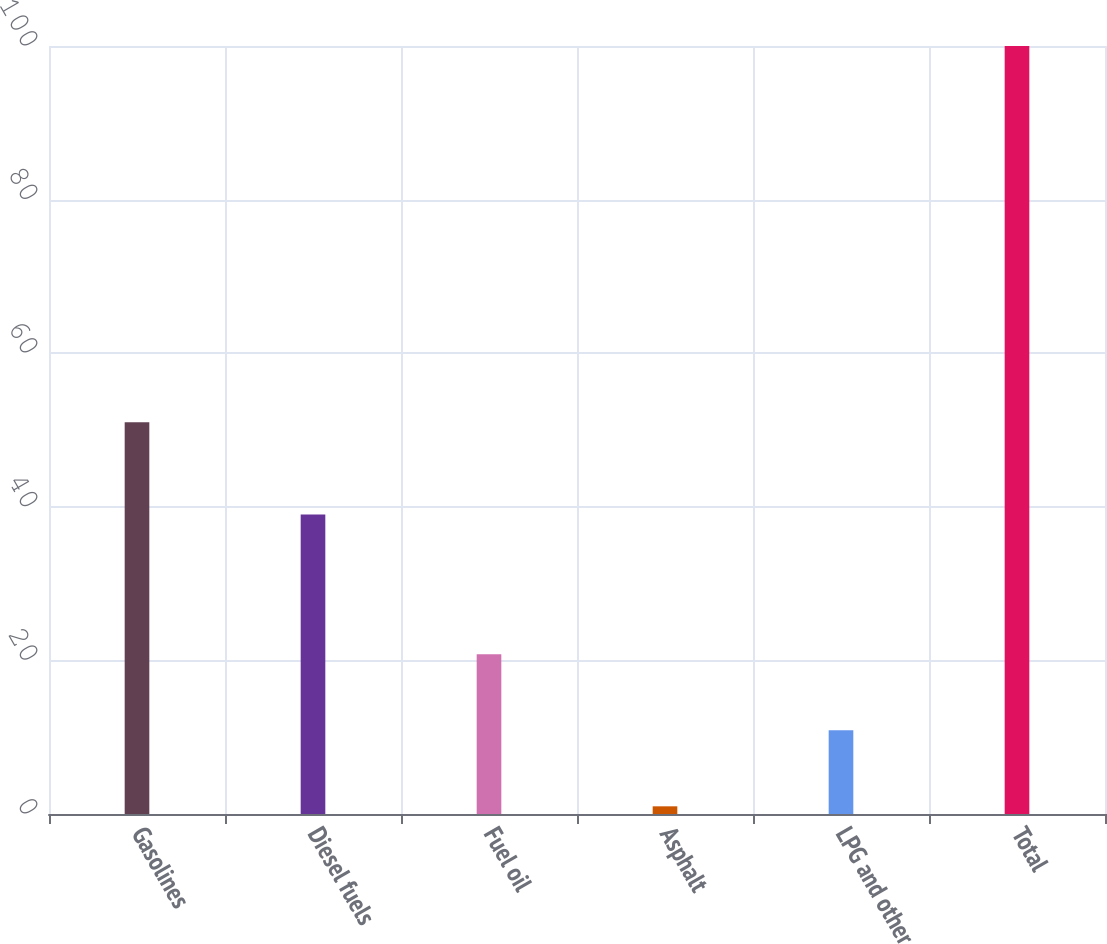Convert chart. <chart><loc_0><loc_0><loc_500><loc_500><bar_chart><fcel>Gasolines<fcel>Diesel fuels<fcel>Fuel oil<fcel>Asphalt<fcel>LPG and other<fcel>Total<nl><fcel>51<fcel>39<fcel>20.8<fcel>1<fcel>10.9<fcel>100<nl></chart> 